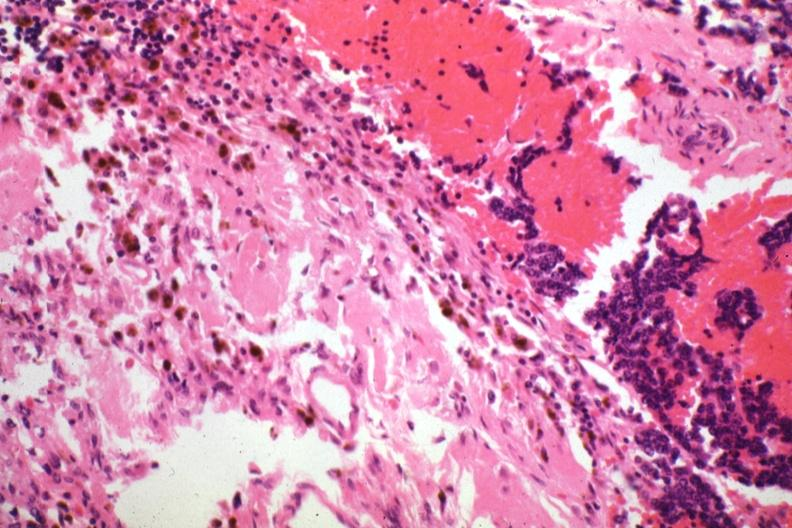what is present?
Answer the question using a single word or phrase. Malignant adenoma 